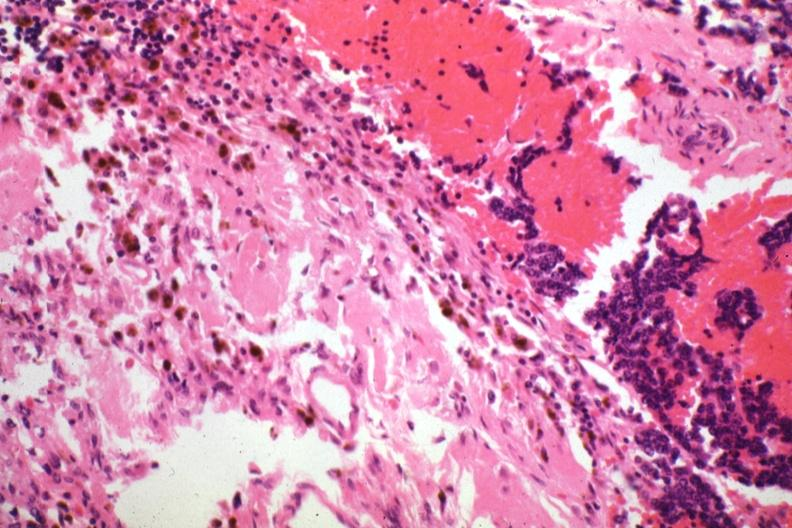what is present?
Answer the question using a single word or phrase. Malignant adenoma 